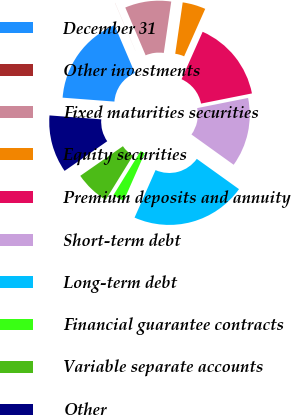Convert chart. <chart><loc_0><loc_0><loc_500><loc_500><pie_chart><fcel>December 31<fcel>Other investments<fcel>Fixed maturities securities<fcel>Equity securities<fcel>Premium deposits and annuity<fcel>Short-term debt<fcel>Long-term debt<fcel>Financial guarantee contracts<fcel>Variable separate accounts<fcel>Other<nl><fcel>17.38%<fcel>0.01%<fcel>8.7%<fcel>4.36%<fcel>15.21%<fcel>13.04%<fcel>21.72%<fcel>2.18%<fcel>6.53%<fcel>10.87%<nl></chart> 